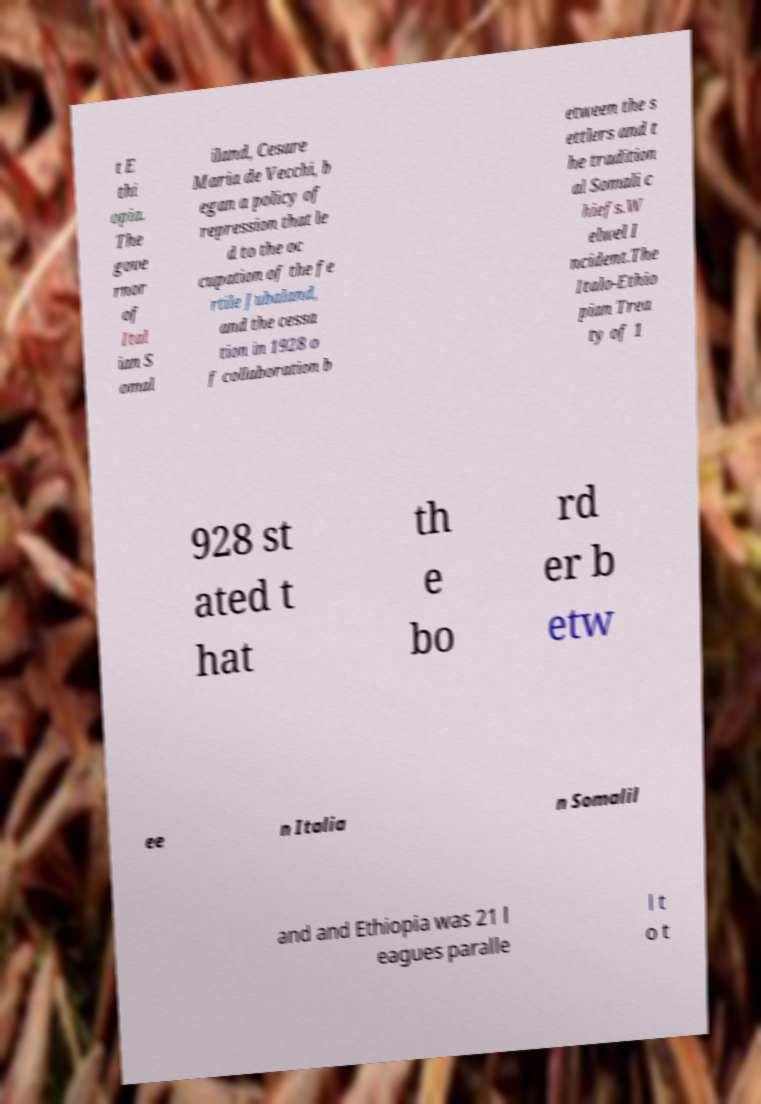Could you assist in decoding the text presented in this image and type it out clearly? t E thi opia. The gove rnor of Ital ian S omal iland, Cesare Maria de Vecchi, b egan a policy of repression that le d to the oc cupation of the fe rtile Jubaland, and the cessa tion in 1928 o f collaboration b etween the s ettlers and t he tradition al Somali c hiefs.W elwel I ncident.The Italo-Ethio pian Trea ty of 1 928 st ated t hat th e bo rd er b etw ee n Italia n Somalil and and Ethiopia was 21 l eagues paralle l t o t 